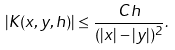<formula> <loc_0><loc_0><loc_500><loc_500>| K ( x , y , h ) | \leq \frac { C h } { ( | x | - | y | ) ^ { 2 } } .</formula> 